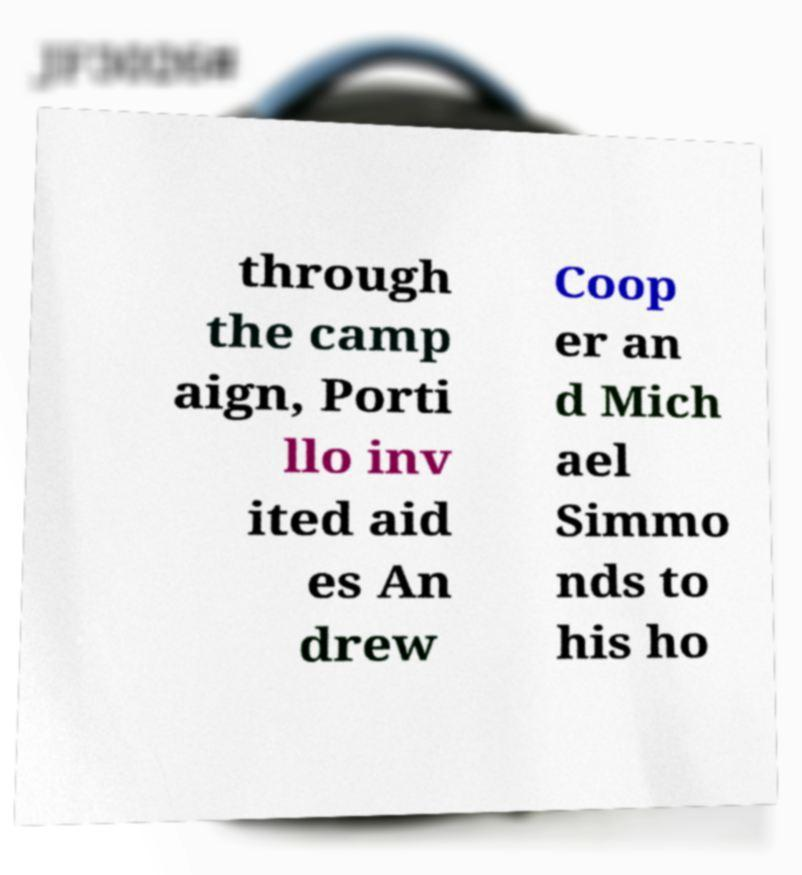What messages or text are displayed in this image? I need them in a readable, typed format. through the camp aign, Porti llo inv ited aid es An drew Coop er an d Mich ael Simmo nds to his ho 